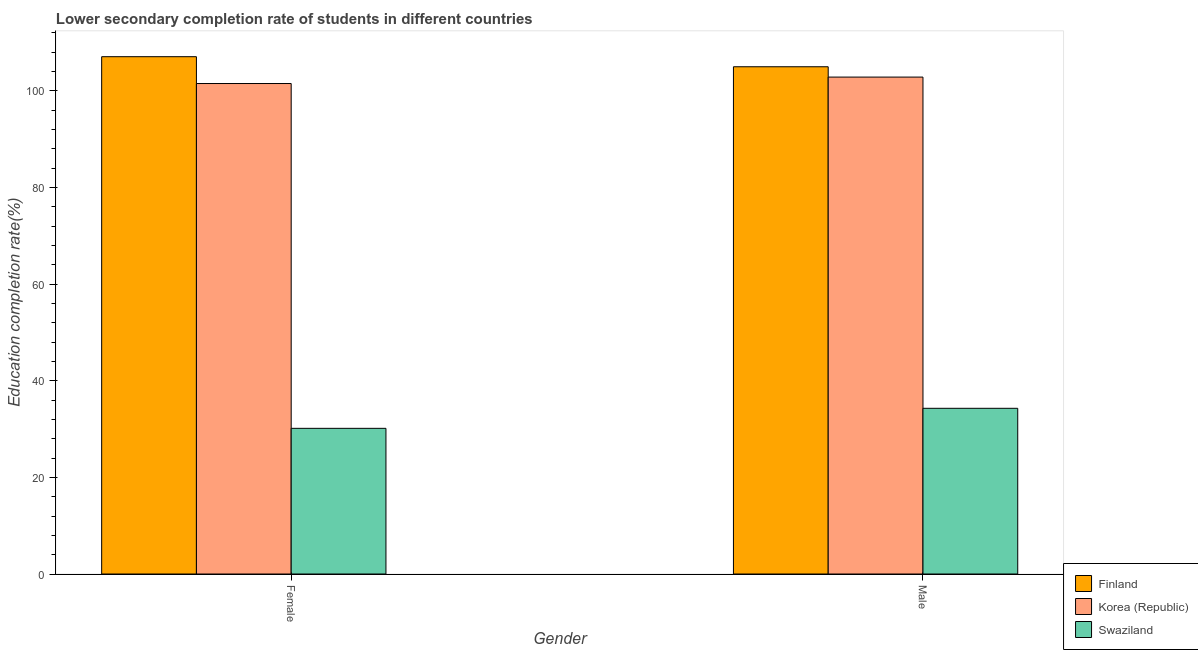How many groups of bars are there?
Your answer should be compact. 2. Are the number of bars per tick equal to the number of legend labels?
Offer a very short reply. Yes. Are the number of bars on each tick of the X-axis equal?
Provide a short and direct response. Yes. How many bars are there on the 1st tick from the left?
Offer a very short reply. 3. What is the education completion rate of female students in Korea (Republic)?
Make the answer very short. 101.53. Across all countries, what is the maximum education completion rate of female students?
Your answer should be very brief. 107.08. Across all countries, what is the minimum education completion rate of male students?
Provide a short and direct response. 34.3. In which country was the education completion rate of female students maximum?
Make the answer very short. Finland. In which country was the education completion rate of female students minimum?
Your answer should be compact. Swaziland. What is the total education completion rate of female students in the graph?
Keep it short and to the point. 238.76. What is the difference between the education completion rate of male students in Swaziland and that in Korea (Republic)?
Ensure brevity in your answer.  -68.56. What is the difference between the education completion rate of male students in Korea (Republic) and the education completion rate of female students in Swaziland?
Make the answer very short. 72.7. What is the average education completion rate of female students per country?
Ensure brevity in your answer.  79.59. What is the difference between the education completion rate of female students and education completion rate of male students in Finland?
Your response must be concise. 2.08. What is the ratio of the education completion rate of female students in Korea (Republic) to that in Swaziland?
Your answer should be very brief. 3.37. Is the education completion rate of male students in Swaziland less than that in Finland?
Provide a short and direct response. Yes. In how many countries, is the education completion rate of female students greater than the average education completion rate of female students taken over all countries?
Ensure brevity in your answer.  2. What does the 3rd bar from the left in Female represents?
Offer a terse response. Swaziland. What does the 3rd bar from the right in Male represents?
Ensure brevity in your answer.  Finland. How many countries are there in the graph?
Your answer should be very brief. 3. What is the difference between two consecutive major ticks on the Y-axis?
Ensure brevity in your answer.  20. Does the graph contain grids?
Provide a short and direct response. No. How many legend labels are there?
Provide a short and direct response. 3. How are the legend labels stacked?
Offer a terse response. Vertical. What is the title of the graph?
Provide a succinct answer. Lower secondary completion rate of students in different countries. Does "Timor-Leste" appear as one of the legend labels in the graph?
Your response must be concise. No. What is the label or title of the Y-axis?
Provide a short and direct response. Education completion rate(%). What is the Education completion rate(%) of Finland in Female?
Offer a terse response. 107.08. What is the Education completion rate(%) in Korea (Republic) in Female?
Your answer should be very brief. 101.53. What is the Education completion rate(%) in Swaziland in Female?
Make the answer very short. 30.15. What is the Education completion rate(%) of Finland in Male?
Make the answer very short. 105. What is the Education completion rate(%) of Korea (Republic) in Male?
Provide a succinct answer. 102.86. What is the Education completion rate(%) in Swaziland in Male?
Your answer should be compact. 34.3. Across all Gender, what is the maximum Education completion rate(%) of Finland?
Provide a succinct answer. 107.08. Across all Gender, what is the maximum Education completion rate(%) of Korea (Republic)?
Offer a very short reply. 102.86. Across all Gender, what is the maximum Education completion rate(%) of Swaziland?
Your answer should be very brief. 34.3. Across all Gender, what is the minimum Education completion rate(%) in Finland?
Your answer should be compact. 105. Across all Gender, what is the minimum Education completion rate(%) in Korea (Republic)?
Your response must be concise. 101.53. Across all Gender, what is the minimum Education completion rate(%) of Swaziland?
Your answer should be very brief. 30.15. What is the total Education completion rate(%) of Finland in the graph?
Your answer should be very brief. 212.08. What is the total Education completion rate(%) of Korea (Republic) in the graph?
Provide a succinct answer. 204.38. What is the total Education completion rate(%) of Swaziland in the graph?
Your answer should be very brief. 64.45. What is the difference between the Education completion rate(%) of Finland in Female and that in Male?
Offer a very short reply. 2.08. What is the difference between the Education completion rate(%) of Korea (Republic) in Female and that in Male?
Your answer should be very brief. -1.33. What is the difference between the Education completion rate(%) of Swaziland in Female and that in Male?
Your response must be concise. -4.15. What is the difference between the Education completion rate(%) in Finland in Female and the Education completion rate(%) in Korea (Republic) in Male?
Offer a very short reply. 4.22. What is the difference between the Education completion rate(%) of Finland in Female and the Education completion rate(%) of Swaziland in Male?
Ensure brevity in your answer.  72.78. What is the difference between the Education completion rate(%) of Korea (Republic) in Female and the Education completion rate(%) of Swaziland in Male?
Provide a succinct answer. 67.23. What is the average Education completion rate(%) of Finland per Gender?
Provide a succinct answer. 106.04. What is the average Education completion rate(%) of Korea (Republic) per Gender?
Provide a succinct answer. 102.19. What is the average Education completion rate(%) in Swaziland per Gender?
Offer a very short reply. 32.23. What is the difference between the Education completion rate(%) in Finland and Education completion rate(%) in Korea (Republic) in Female?
Offer a very short reply. 5.55. What is the difference between the Education completion rate(%) of Finland and Education completion rate(%) of Swaziland in Female?
Your response must be concise. 76.93. What is the difference between the Education completion rate(%) of Korea (Republic) and Education completion rate(%) of Swaziland in Female?
Provide a succinct answer. 71.37. What is the difference between the Education completion rate(%) in Finland and Education completion rate(%) in Korea (Republic) in Male?
Offer a terse response. 2.14. What is the difference between the Education completion rate(%) in Finland and Education completion rate(%) in Swaziland in Male?
Your answer should be compact. 70.7. What is the difference between the Education completion rate(%) in Korea (Republic) and Education completion rate(%) in Swaziland in Male?
Provide a short and direct response. 68.56. What is the ratio of the Education completion rate(%) of Finland in Female to that in Male?
Offer a very short reply. 1.02. What is the ratio of the Education completion rate(%) in Korea (Republic) in Female to that in Male?
Offer a very short reply. 0.99. What is the ratio of the Education completion rate(%) in Swaziland in Female to that in Male?
Offer a very short reply. 0.88. What is the difference between the highest and the second highest Education completion rate(%) in Finland?
Ensure brevity in your answer.  2.08. What is the difference between the highest and the second highest Education completion rate(%) in Korea (Republic)?
Offer a terse response. 1.33. What is the difference between the highest and the second highest Education completion rate(%) in Swaziland?
Keep it short and to the point. 4.15. What is the difference between the highest and the lowest Education completion rate(%) of Finland?
Your response must be concise. 2.08. What is the difference between the highest and the lowest Education completion rate(%) of Korea (Republic)?
Make the answer very short. 1.33. What is the difference between the highest and the lowest Education completion rate(%) in Swaziland?
Ensure brevity in your answer.  4.15. 